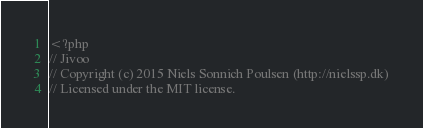<code> <loc_0><loc_0><loc_500><loc_500><_PHP_><?php
// Jivoo
// Copyright (c) 2015 Niels Sonnich Poulsen (http://nielssp.dk)
// Licensed under the MIT license.</code> 